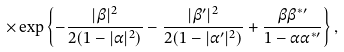Convert formula to latex. <formula><loc_0><loc_0><loc_500><loc_500>\times \exp \left \{ - \frac { | \beta | ^ { 2 } } { 2 ( 1 - | \alpha | ^ { 2 } ) } - \frac { | \beta ^ { \prime } | ^ { 2 } } { 2 ( 1 - | \alpha ^ { \prime } | ^ { 2 } ) } + \frac { \beta \beta ^ { * \prime } } { 1 - \alpha \alpha ^ { * \prime } } \right \} ,</formula> 